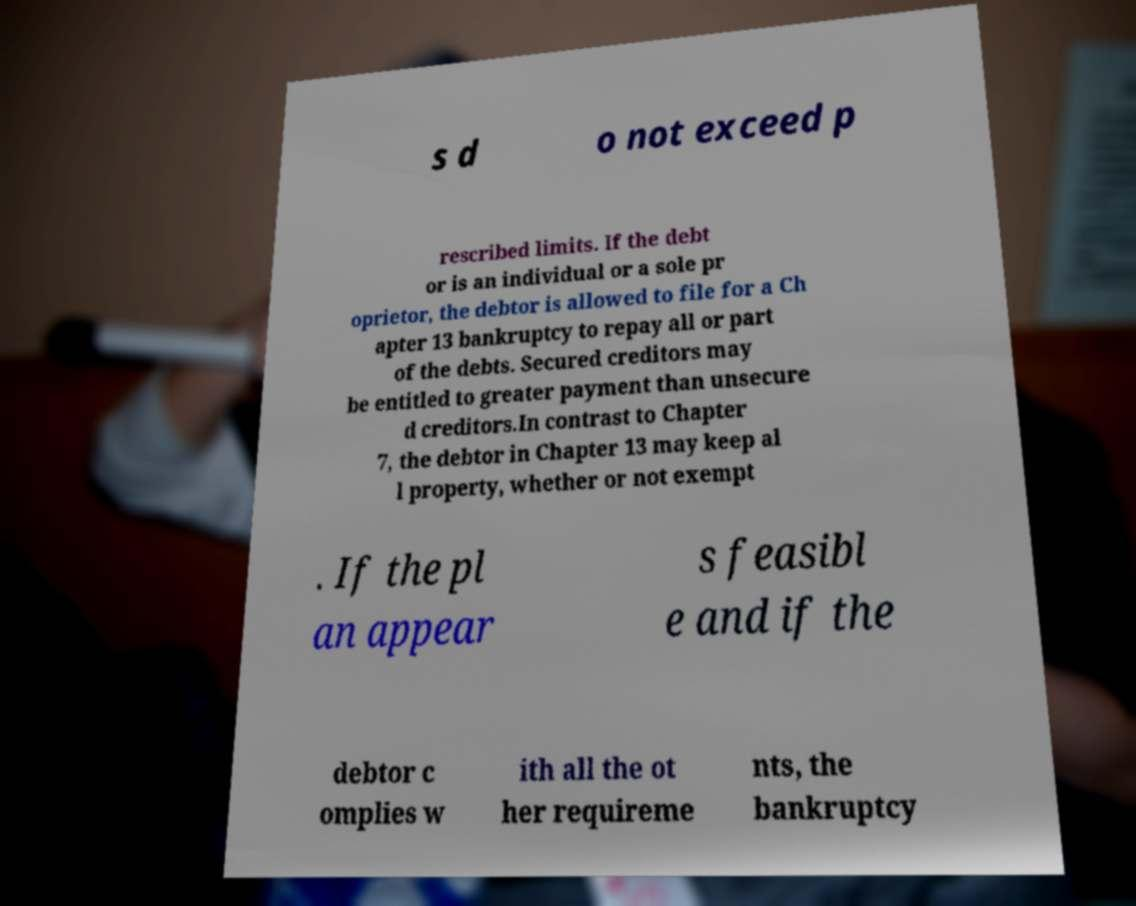For documentation purposes, I need the text within this image transcribed. Could you provide that? s d o not exceed p rescribed limits. If the debt or is an individual or a sole pr oprietor, the debtor is allowed to file for a Ch apter 13 bankruptcy to repay all or part of the debts. Secured creditors may be entitled to greater payment than unsecure d creditors.In contrast to Chapter 7, the debtor in Chapter 13 may keep al l property, whether or not exempt . If the pl an appear s feasibl e and if the debtor c omplies w ith all the ot her requireme nts, the bankruptcy 